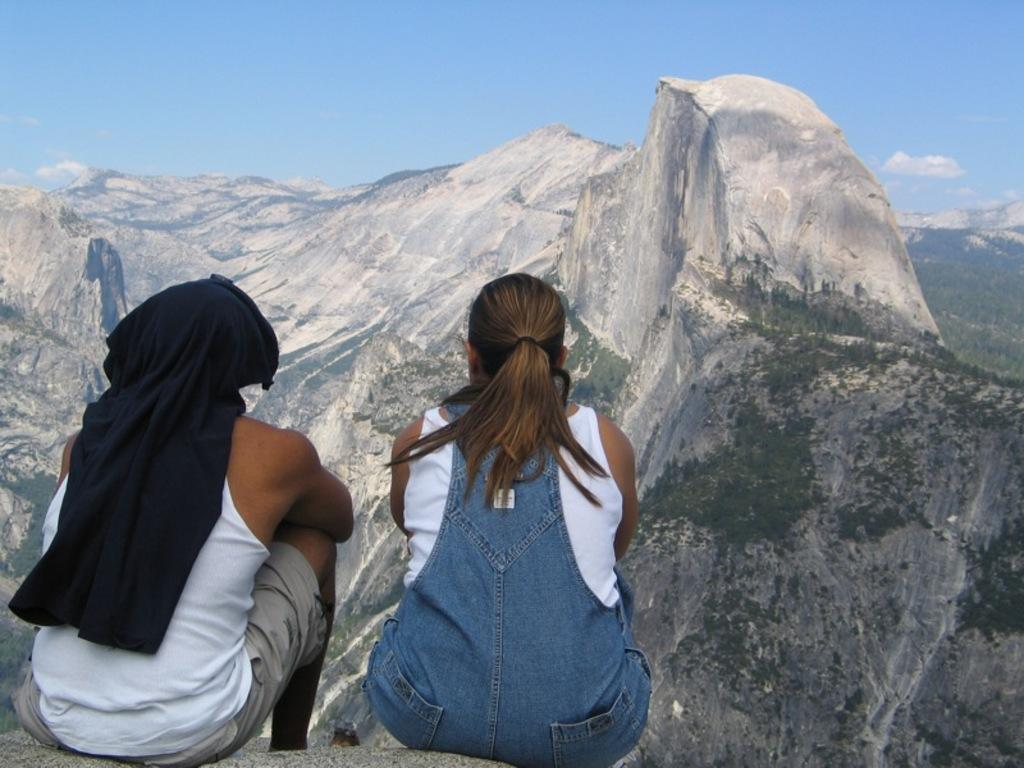How many people are sitting on the stone in the image? There are two people sitting on a stone in the image. What type of natural landscape can be seen in the image? Mountains and trees are visible in the image. What part of the natural environment is visible in the image? The sky is visible in the image. What type of insect is crawling on the army during the meeting in the image? There is no insect, army, or meeting present in the image. 